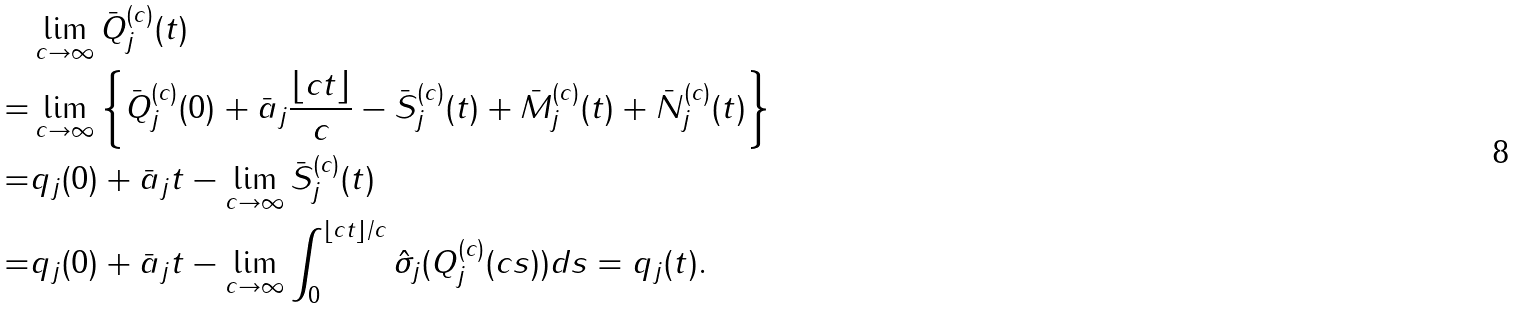Convert formula to latex. <formula><loc_0><loc_0><loc_500><loc_500>& \lim _ { c \rightarrow \infty } \bar { Q } ^ { ( c ) } _ { j } ( t ) \\ = & \lim _ { c \rightarrow \infty } \left \{ \bar { Q } ^ { ( c ) } _ { j } ( 0 ) + \bar { a } _ { j } \frac { \lfloor c t \rfloor } { c } - \bar { S } ^ { ( c ) } _ { j } ( t ) + \bar { M } ^ { ( c ) } _ { j } ( t ) + \bar { N } ^ { ( c ) } _ { j } ( t ) \right \} \\ = & q _ { j } ( 0 ) + \bar { a } _ { j } t - \lim _ { c \rightarrow \infty } \bar { S } ^ { ( c ) } _ { j } ( t ) \\ = & q _ { j } ( 0 ) + \bar { a } _ { j } t - \lim _ { c \rightarrow \infty } \int _ { 0 } ^ { { \lfloor c t \rfloor } / { c } } \hat { \sigma } _ { j } ( { Q } ^ { ( c ) } _ { j } ( c s ) ) d s = q _ { j } ( t ) .</formula> 